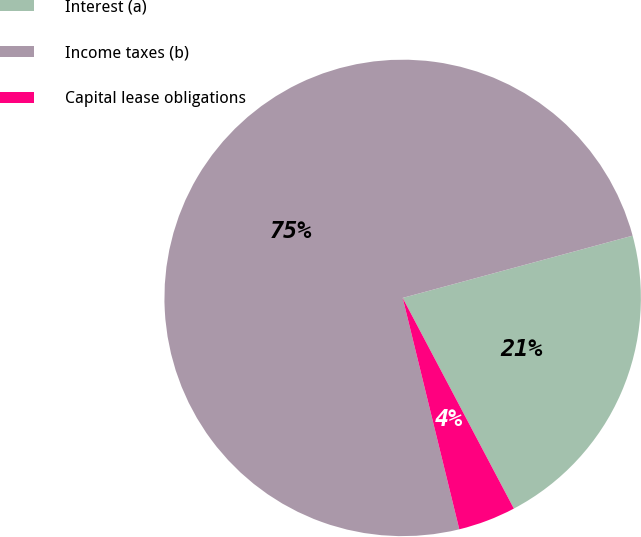Convert chart to OTSL. <chart><loc_0><loc_0><loc_500><loc_500><pie_chart><fcel>Interest (a)<fcel>Income taxes (b)<fcel>Capital lease obligations<nl><fcel>21.48%<fcel>74.62%<fcel>3.91%<nl></chart> 